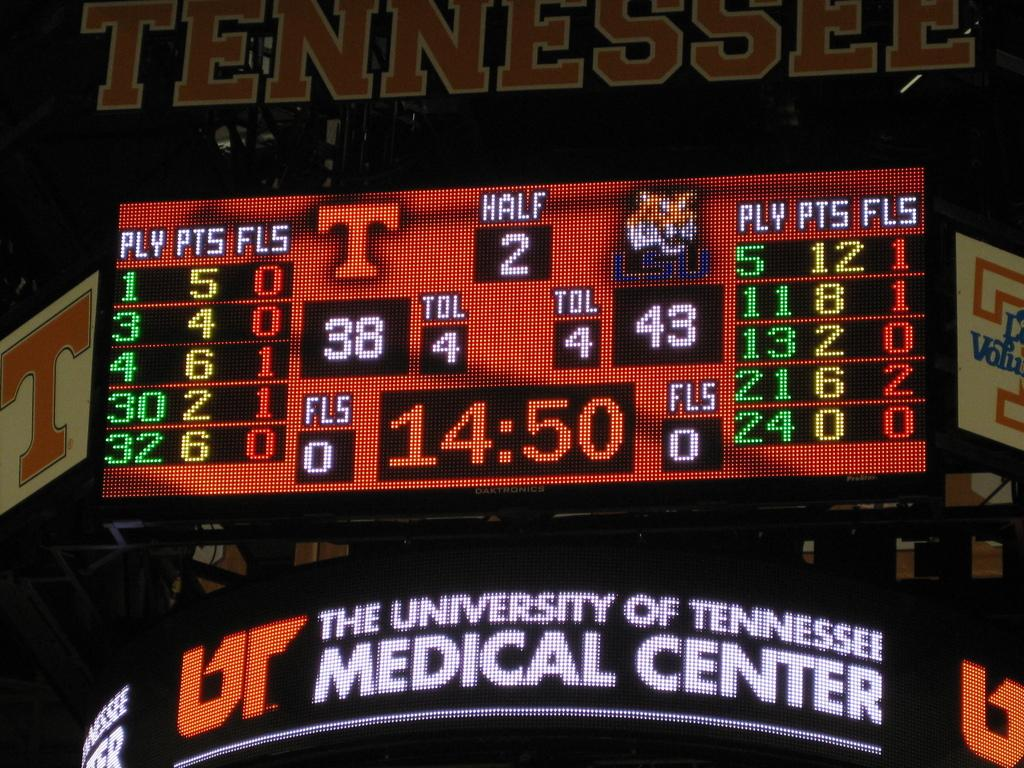Provide a one-sentence caption for the provided image. A digital sign for the University of Tennesse's Medical Center. 